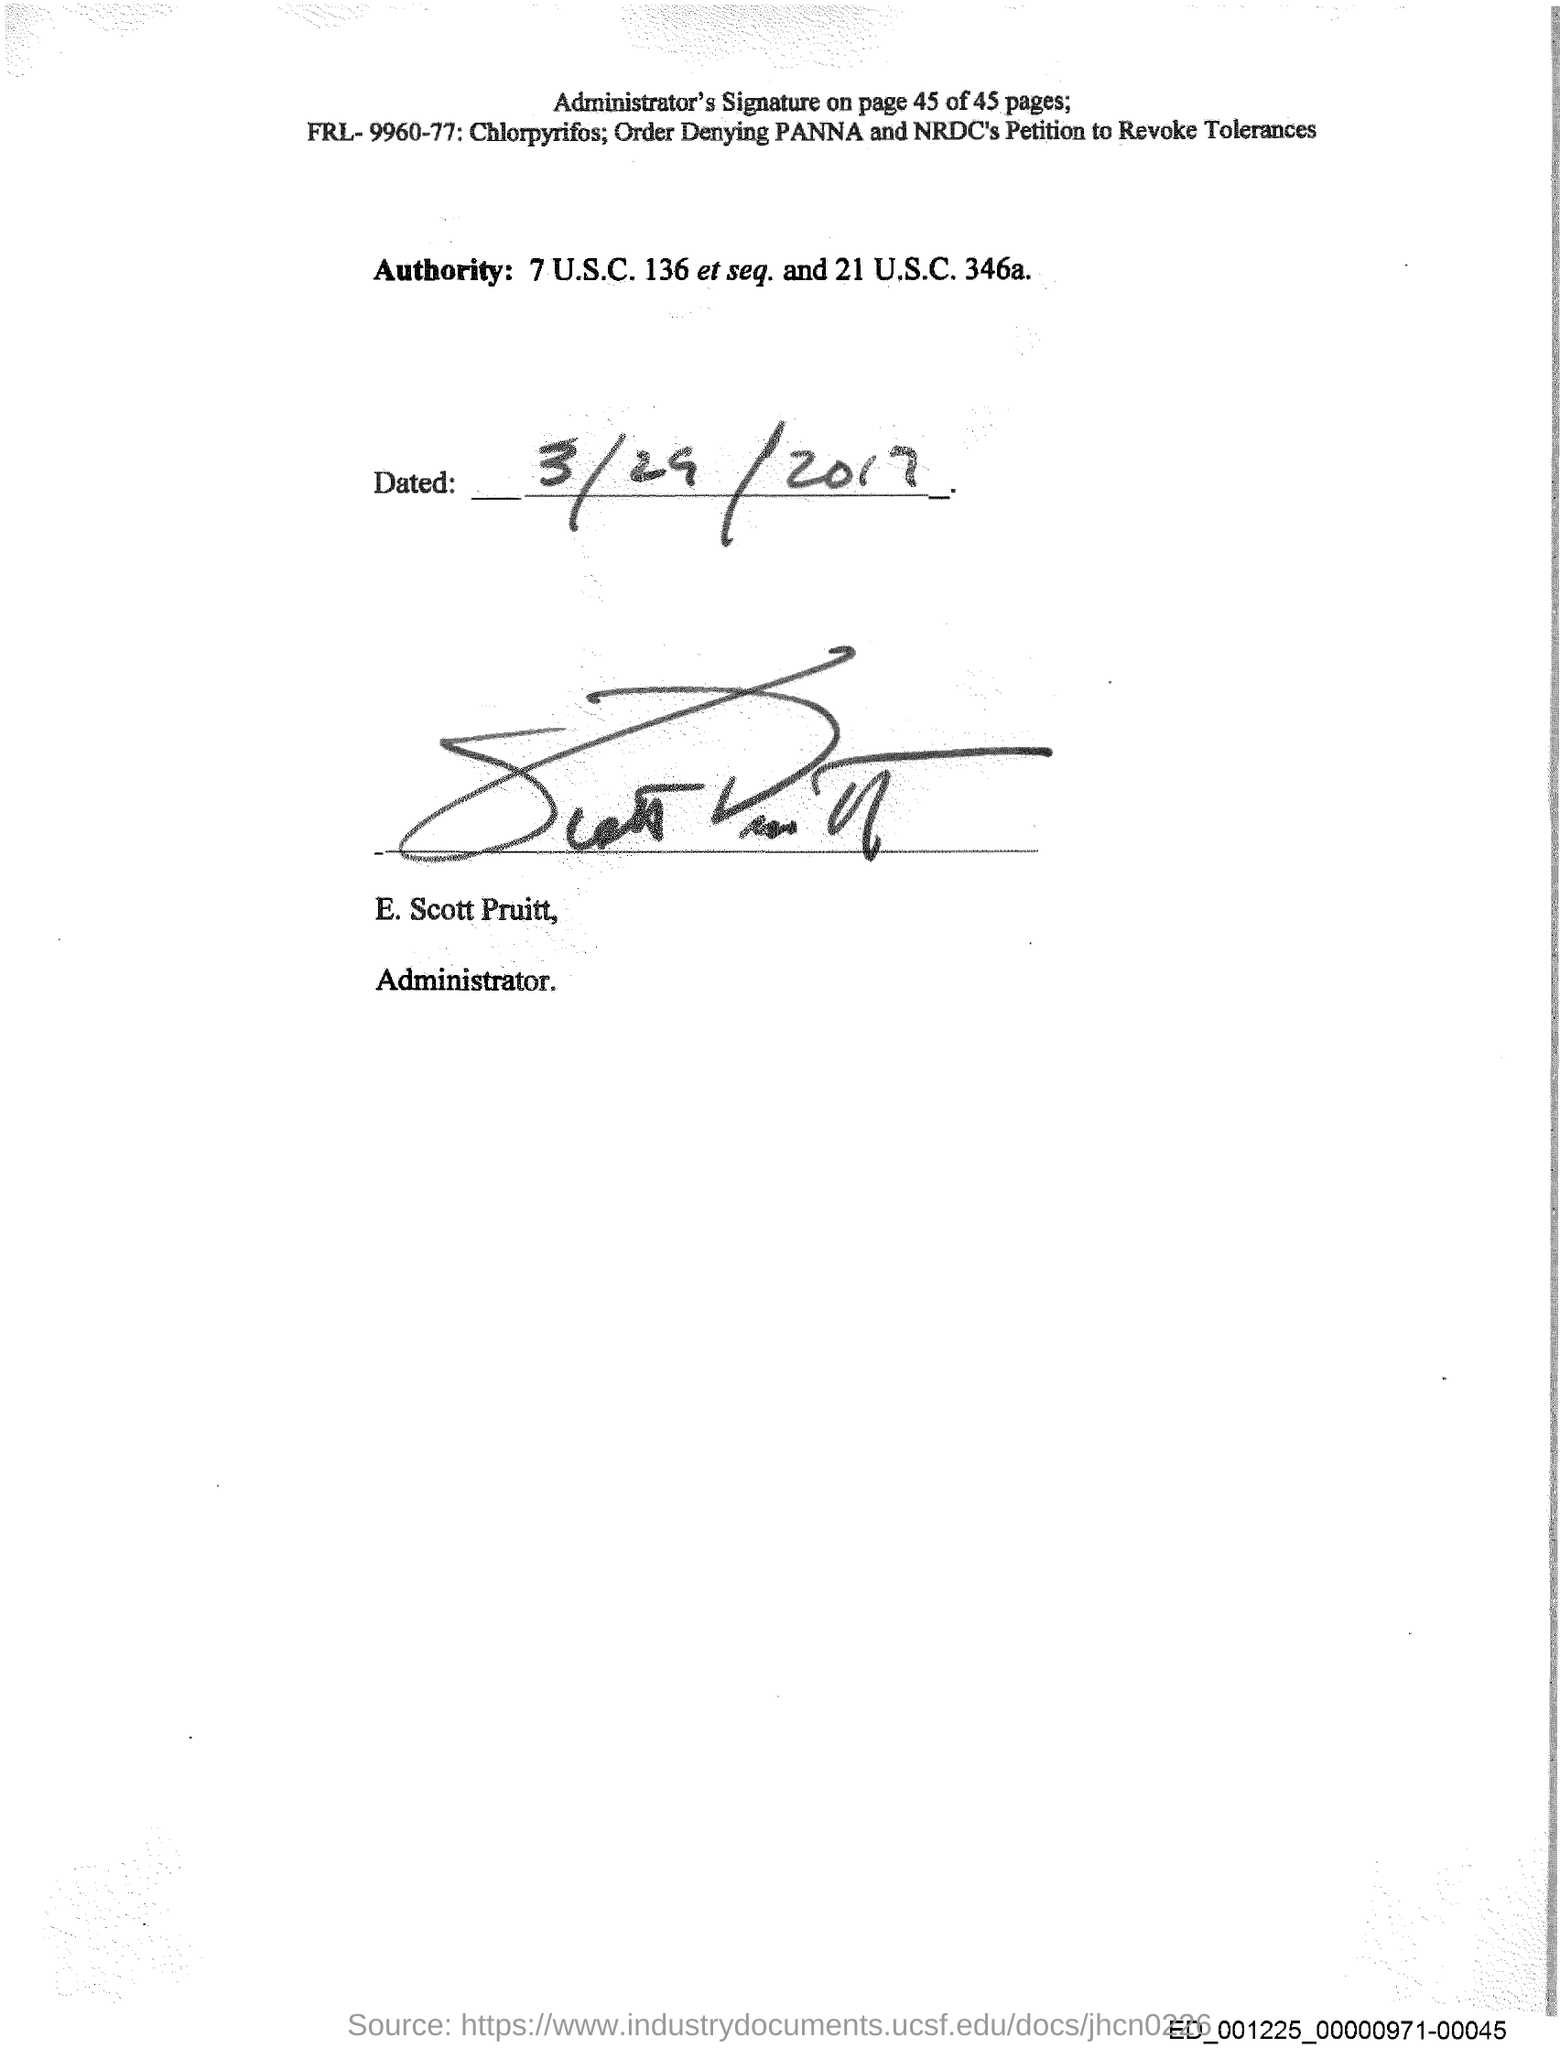Point out several critical features in this image. E. Scott Pruitt is the administrator of a certain organization. The person who signed the document is E. Scott Pruitt. The handwritten date above the signature is "3/29/2017. 